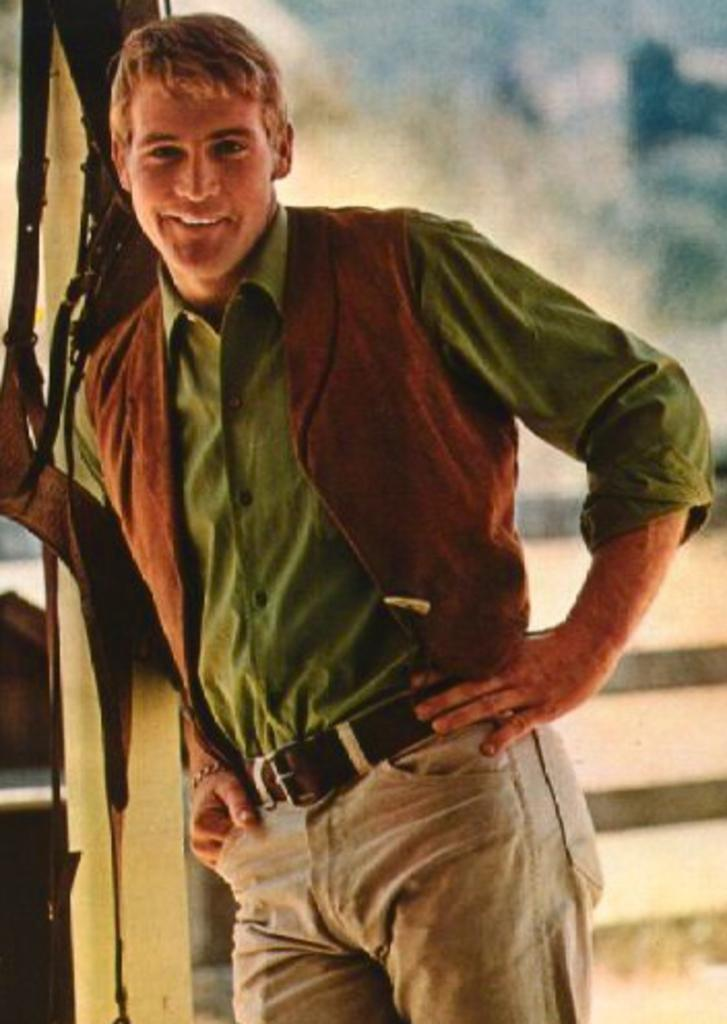What is the main subject of the image? There is a person in the image. What is the person doing in the image? The person is smiling. What architectural feature is visible behind the person? There are stairs behind the person. What can be seen in the background of the image? The sky is visible in the background of the image. What type of sack can be seen hanging from the person's shoulder in the image? There is no sack visible in the image; the person is not carrying anything on their shoulder. Can you recite a verse that is written on the person's shirt in the image? There is no verse written on the person's shirt in the image; the shirt is not visible in the provided facts. 